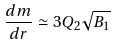Convert formula to latex. <formula><loc_0><loc_0><loc_500><loc_500>\frac { d m } { d r } \simeq 3 Q _ { 2 } \sqrt { B _ { 1 } }</formula> 